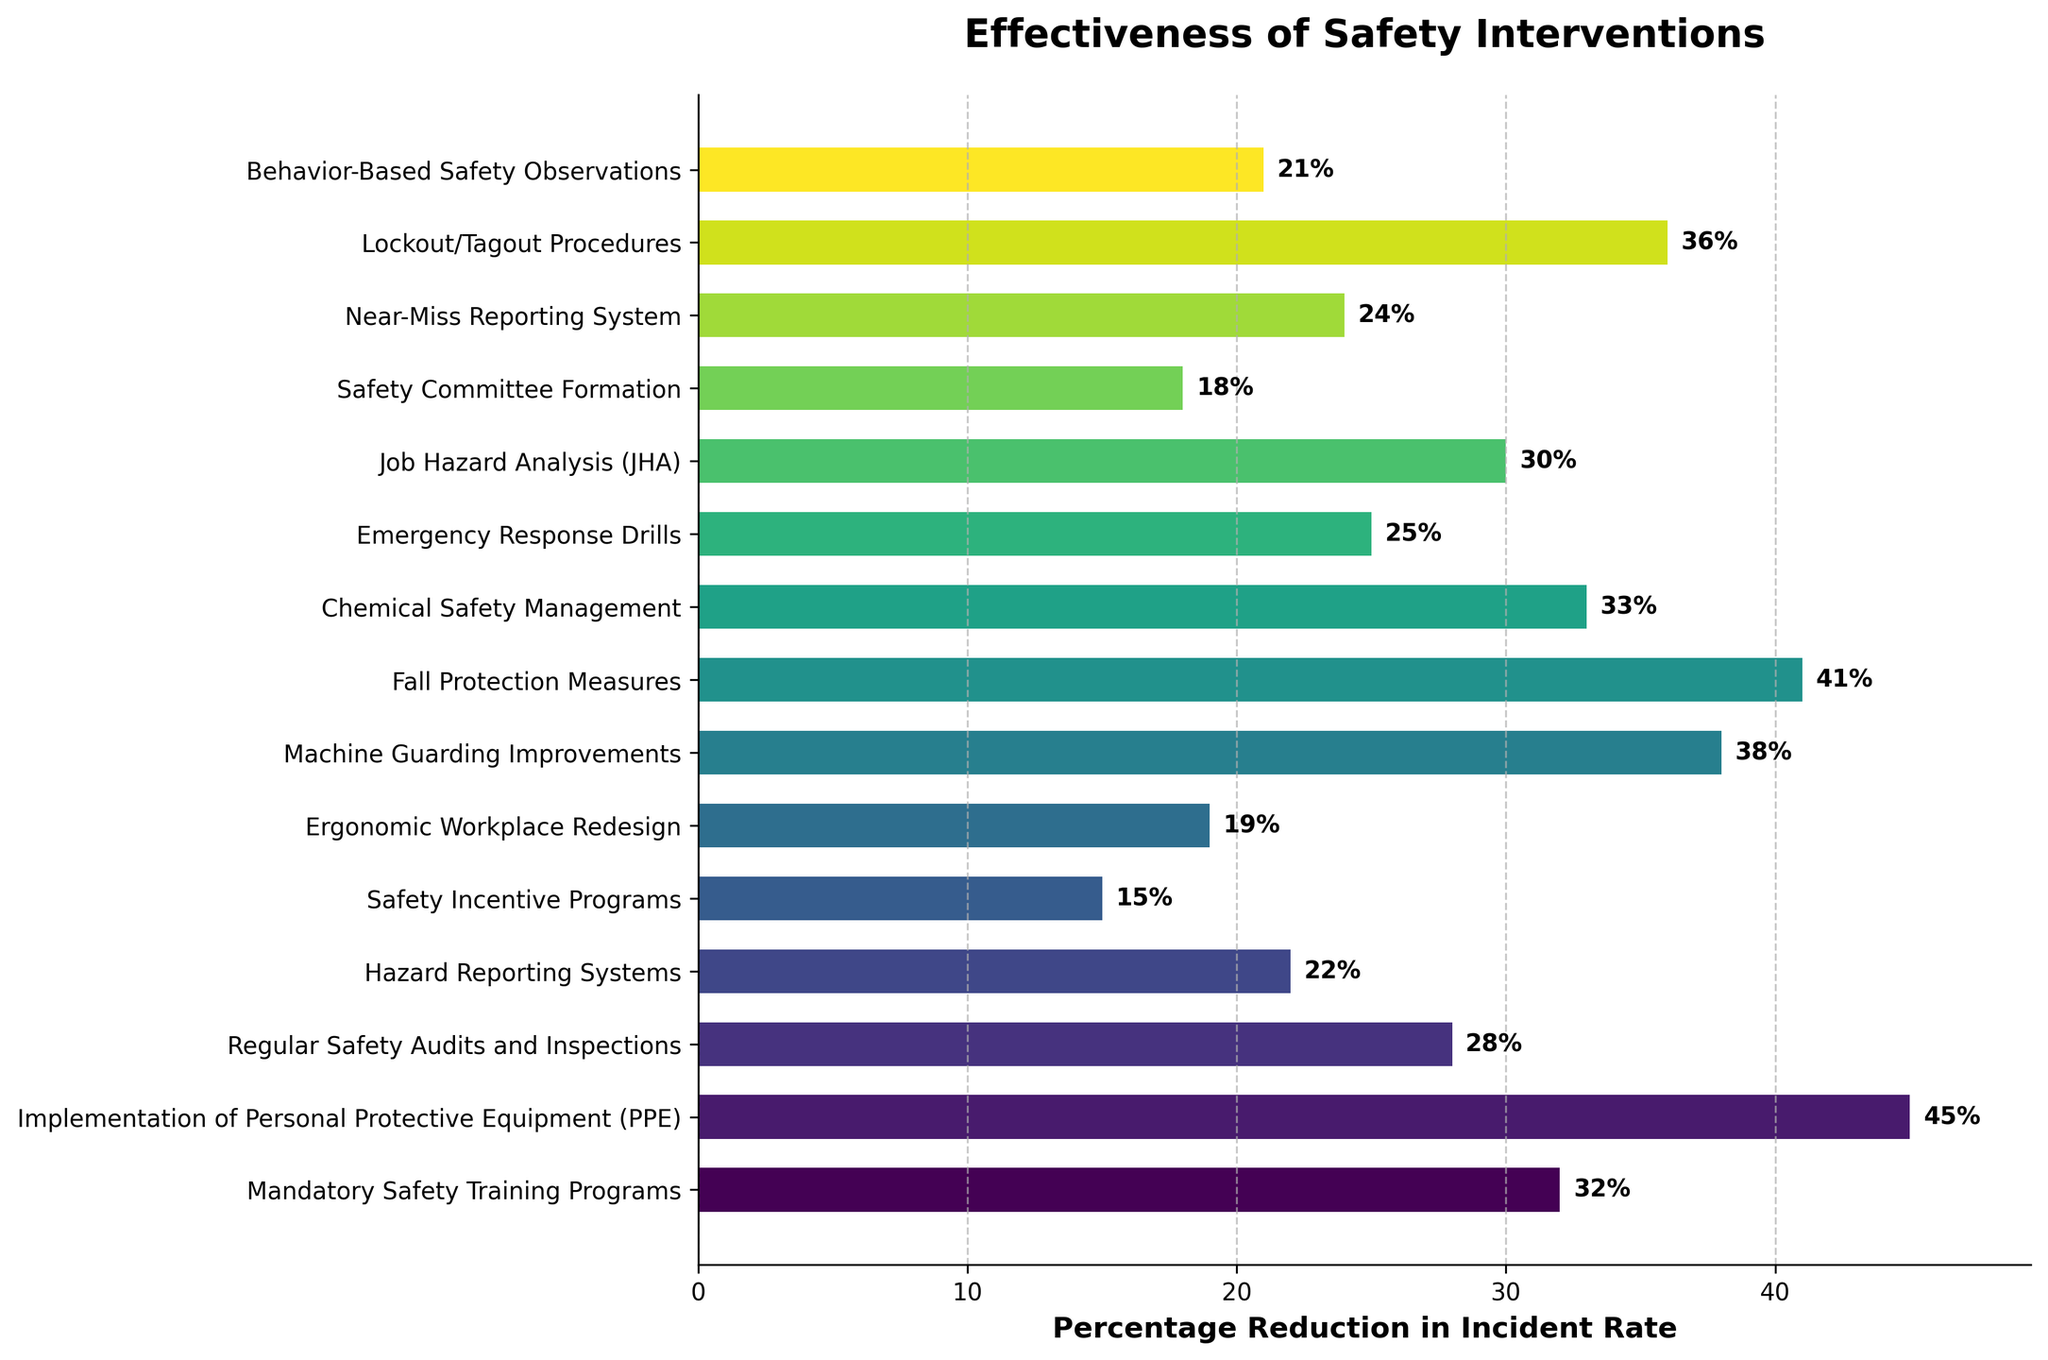What is the highest percentage reduction in incident rates? The highest percentage reduction is indicated by the longest bar in the horizontal bar chart. Identify the intervention with the longest bar and read the value next to it.
Answer: 45% Which safety intervention has the lowest percentage reduction in incident rates? Look for the shortest bar in the chart and identify the corresponding safety intervention and its percentage reduction.
Answer: Safety Incentive Programs (15%) What is the difference in percentage reduction between the highest and lowest interventions? First, identify the highest value (45%) and the lowest value (15%). Subtract the lowest value from the highest value: 45% - 15% = 30%.
Answer: 30% Among the interventions shown, which two have the closest percentage reduction in incident rates? Compare the values of all the bars and find the two values that have the smallest numerical difference between them. For example, Machine Guarding Improvements (38%) and Lockout/Tagout Procedures (36%) have a difference of 2%.
Answer: Machine Guarding Improvements and Lockout/Tagout Procedures How many interventions have a percentage reduction of 30% or more? Count the number of bars that have a value greater than or equal to 30%.
Answer: 7 What is the average percentage reduction in incident rates across all interventions? Sum all the percentage reductions and then divide by the number of interventions: (32 + 45 + 28 + 22 + 15 + 19 + 38 + 41 + 33 + 25 + 30 + 18 + 24 + 36 + 21) / 15.
Answer: 29.3% Which safety intervention has a percentage reduction closest to the average reduction rate? Calculate the average reduction rate and find the bar whose value is closest to this average. Compare the average (29.3%) to the values to find the closest match.
Answer: Job Hazard Analysis (30%) What is the combined percentage reduction in incident rates for the three most effective interventions? Identify the three bars with the highest values: Implementation of PPE (45%), Fall Protection Measures (41%), and Machine Guarding Improvements (38%). Sum these values: 45% + 41% + 38% = 124%.
Answer: 124% Do any two interventions have the same percentage reduction? Compare all the percentage reduction values for each intervention to see if any two share the same value.
Answer: No How much more effective is Mandatory Safety Training Programs compared to Safety Incentive Programs? Look at the percentage reduction for both interventions: Mandatory Safety Training Programs (32%) and Safety Incentive Programs (15%). Subtract the lower value from the higher value: 32% - 15% = 17%.
Answer: 17% 